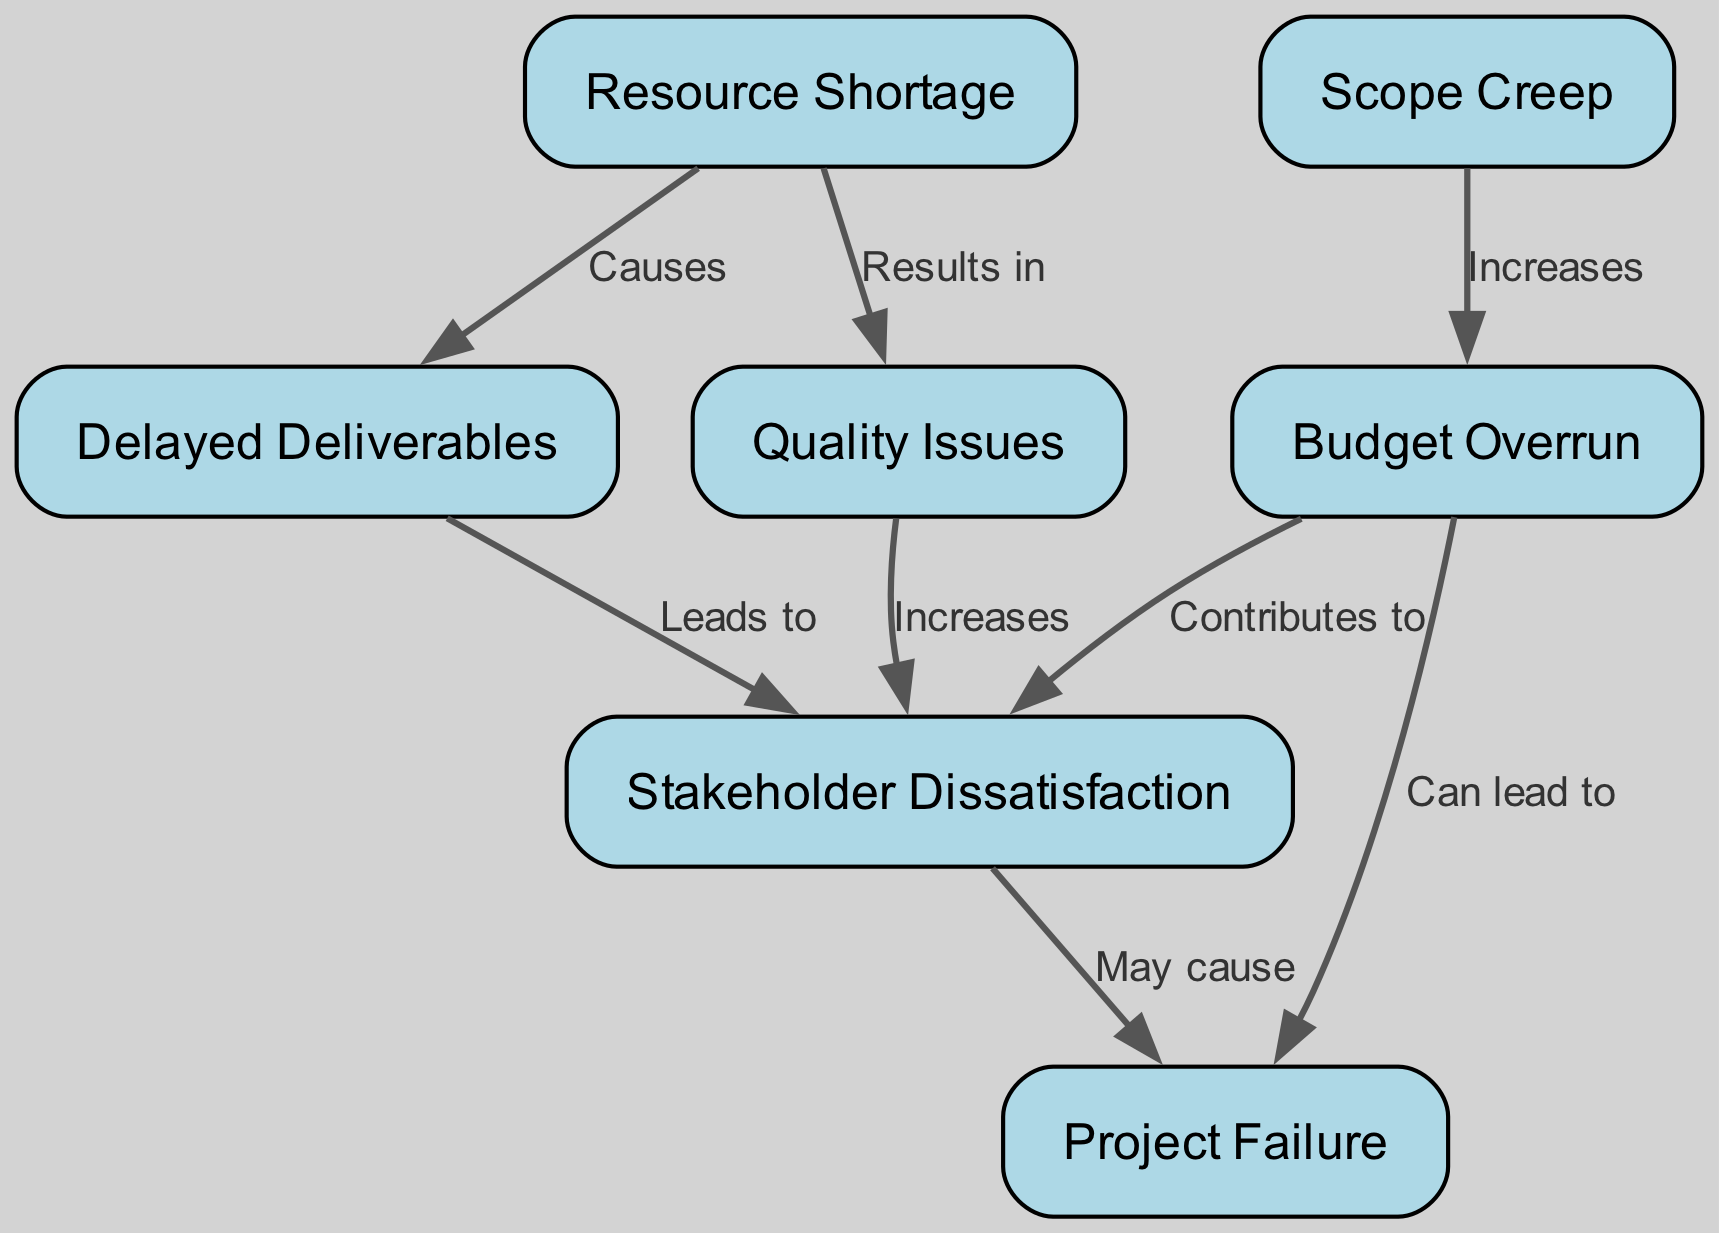What is the total number of nodes in the diagram? Counting the items listed in the "nodes" section of the data, there are 7 unique risk entities identified: Budget Overrun, Scope Creep, Resource Shortage, Delayed Deliverables, Stakeholder Dissatisfaction, Quality Issues, and Project Failure.
Answer: 7 Which risk is indicated as a result of 'Resource Shortage'? The edge showing the relationship between Resource Shortage and Delayed Deliverables indicates that Resource Shortage causes Delayed Deliverables.
Answer: Delayed Deliverables How many risks lead to 'Stakeholder Dissatisfaction'? By examining the incoming edges to Stakeholder Dissatisfaction, we see that there are two risks that directly lead to it: Quality Issues and Budget Overrun.
Answer: 2 What is the relationship between 'Budget Overrun' and 'Project Failure'? The graph shows that Budget Overrun can lead to Project Failure, as indicated by the directed edge between these two nodes.
Answer: Can lead to Which risk has the most incoming edges? Analyzing the edges, Stakeholder Dissatisfaction has the highest number of incoming connections, with three edges directed towards it: from Quality Issues, Budget Overrun, and Delayed Deliverables.
Answer: Stakeholder Dissatisfaction What does 'Quality Issues' increase? According to the edge leading from Quality Issues to Stakeholder Dissatisfaction, it indicates that Quality Issues increases Stakeholder Dissatisfaction.
Answer: Increases If 'Scope Creep' is managed effectively, how might it affect 'Budget Overrun'? The diagram illustrates that Scope Creep directly increases Budget Overrun, meaning effective management of Scope Creep will likely result in a decrease of Budget Overrun risks.
Answer: Increases What are the implications of a 'Budget Overrun' on 'Project Failure'? The edges indicate that both Budget Overrun and Stakeholder Dissatisfaction can lead to Project Failure, highlighting a clear risk linkage.
Answer: Can lead to How many edges are connected to the node 'Delayed Deliverables'? By inspecting the edges connected to Delayed Deliverables, there is one edge leading to Stakeholder Dissatisfaction, representing the relationship between them.
Answer: 1 